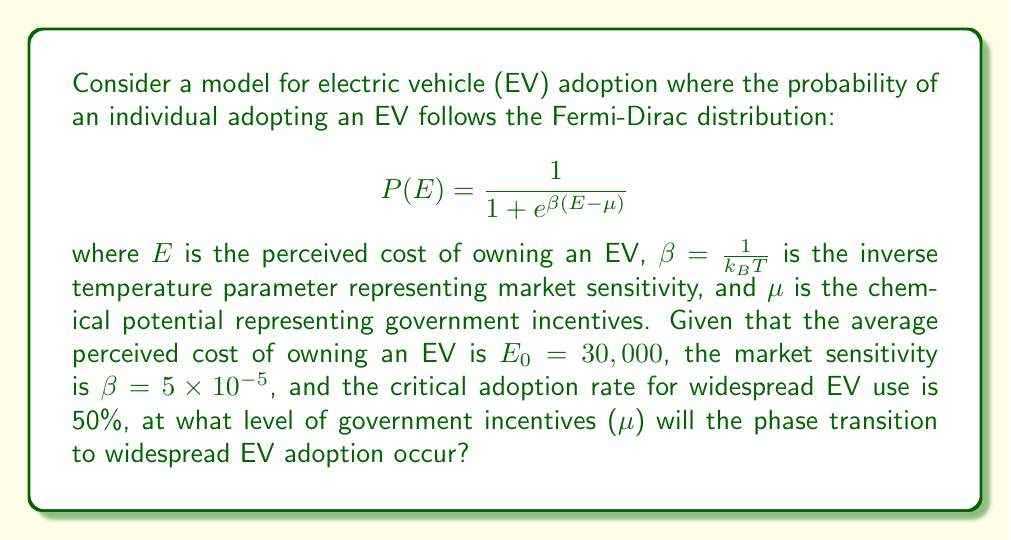Help me with this question. To solve this problem, we'll follow these steps:

1) The phase transition point occurs when the probability of adoption reaches 50%. This means:

   $$P(E_0) = 0.5$$

2) Substituting this into the Fermi-Dirac distribution:

   $$0.5 = \frac{1}{1 + e^{\beta(E_0-\mu)}}$$

3) Simplifying:

   $$1 = 1 + e^{\beta(E_0-\mu)}$$
   $$0 = e^{\beta(E_0-\mu)}$$

4) Taking the natural logarithm of both sides:

   $$\ln(0) = \beta(E_0-\mu)$$

5) Since $\ln(0)$ is undefined, we need to approach this limit:

   $$\lim_{x \to 0^+} \ln(x) = -\infty$$

   This means $\beta(E_0-\mu)$ should approach negative infinity for the equation to hold.

6) In practical terms, this occurs when:

   $$E_0 = \mu$$

7) Therefore, the phase transition occurs when the government incentives ($\mu$) equal the average perceived cost of owning an EV ($E_0$).

8) Substituting the given value:

   $$\mu = E_0 = 30,000$$

Thus, the government incentives should be $30,000 to trigger the phase transition to widespread EV adoption.
Answer: $\mu = 30,000$ 